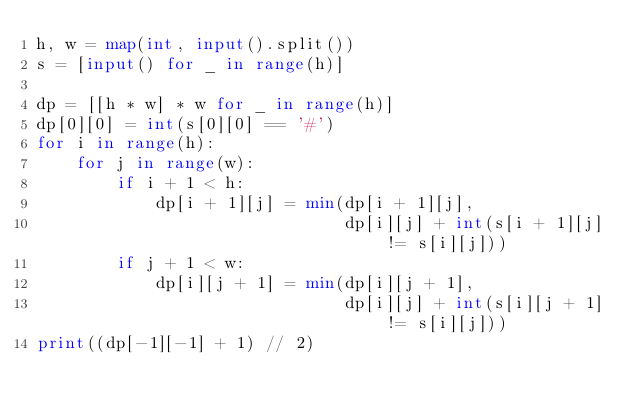Convert code to text. <code><loc_0><loc_0><loc_500><loc_500><_Python_>h, w = map(int, input().split())
s = [input() for _ in range(h)]

dp = [[h * w] * w for _ in range(h)]
dp[0][0] = int(s[0][0] == '#')
for i in range(h):
    for j in range(w):
        if i + 1 < h:
            dp[i + 1][j] = min(dp[i + 1][j],
                               dp[i][j] + int(s[i + 1][j] != s[i][j]))
        if j + 1 < w:
            dp[i][j + 1] = min(dp[i][j + 1],
                               dp[i][j] + int(s[i][j + 1] != s[i][j]))
print((dp[-1][-1] + 1) // 2)
</code> 